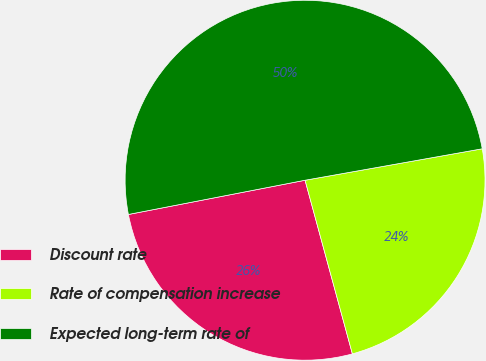<chart> <loc_0><loc_0><loc_500><loc_500><pie_chart><fcel>Discount rate<fcel>Rate of compensation increase<fcel>Expected long-term rate of<nl><fcel>26.19%<fcel>23.56%<fcel>50.25%<nl></chart> 